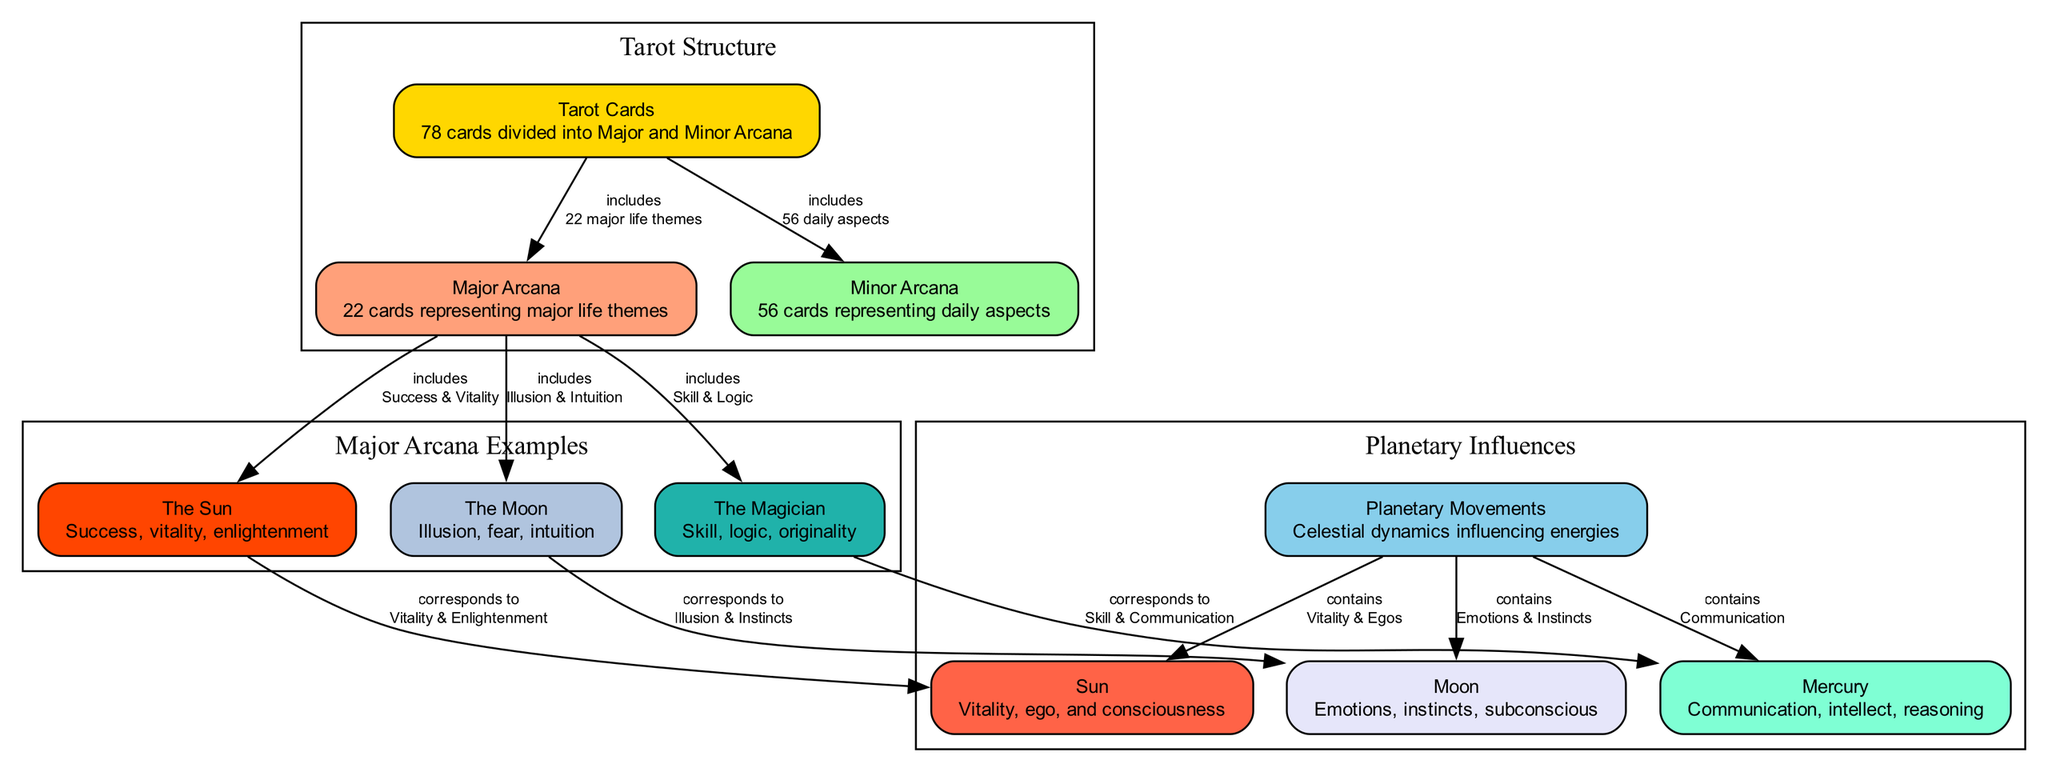What is the total number of nodes in the diagram? The diagram contains all the unique entities represented as nodes. There are 10 nodes listed under "nodes" in the provided data: Tarot Cards, Planetary Movements, Major Arcana, Minor Arcana, Sun, Moon, Mercury, The Sun card, The Moon card, and The Magician card.
Answer: 10 Which tarot card corresponds to the Moon? The relationship can be found by observing the connections made in the diagram. The Moon card is connected to the Moon, indicating that they correspond to each other.
Answer: The Moon How many cards are in the Major Arcana? The number of Major Arcana cards is explicitly mentioned in the description of the Tarot Cards node. It states that there are 22 Major Arcana cards.
Answer: 22 What aspect does the Sun influence? To find this, we look at the connection between the Planetary Movements node and the Sun node. The description states that the Sun influences vitality and ego, showing the aspect it pertains to.
Answer: Vitality & Egos Which tarot card represents skill and logic? By examining the connections within the Major Arcana examples in the diagram, we find that "The Magician" card includes the principles of skill and logic.
Answer: The Magician What is included in the Minor Arcana? The Minor Arcana is listed as a subset of the Tarot Cards, which specifically includes daily aspects according to its description in the diagram.
Answer: 56 daily aspects Which planetary movement corresponds to The Magician card? To determine this, we examine the connection between The Magician card and the Mercury node. The relationship denotes that The Magician corresponds to Mercury, which is related to skill and communication.
Answer: Mercury What color represents the Planets in the diagram? The color coding provided in the data specifies that the Planets node is colored in light blue (#87CEEB), which represents it in the diagram.
Answer: #87CEEB What does the Moon card symbolize? The Moon card's description indicates that it symbolizes illusion, fear, and intuition, highlighting its meanings.
Answer: Illusion, fear, intuition 